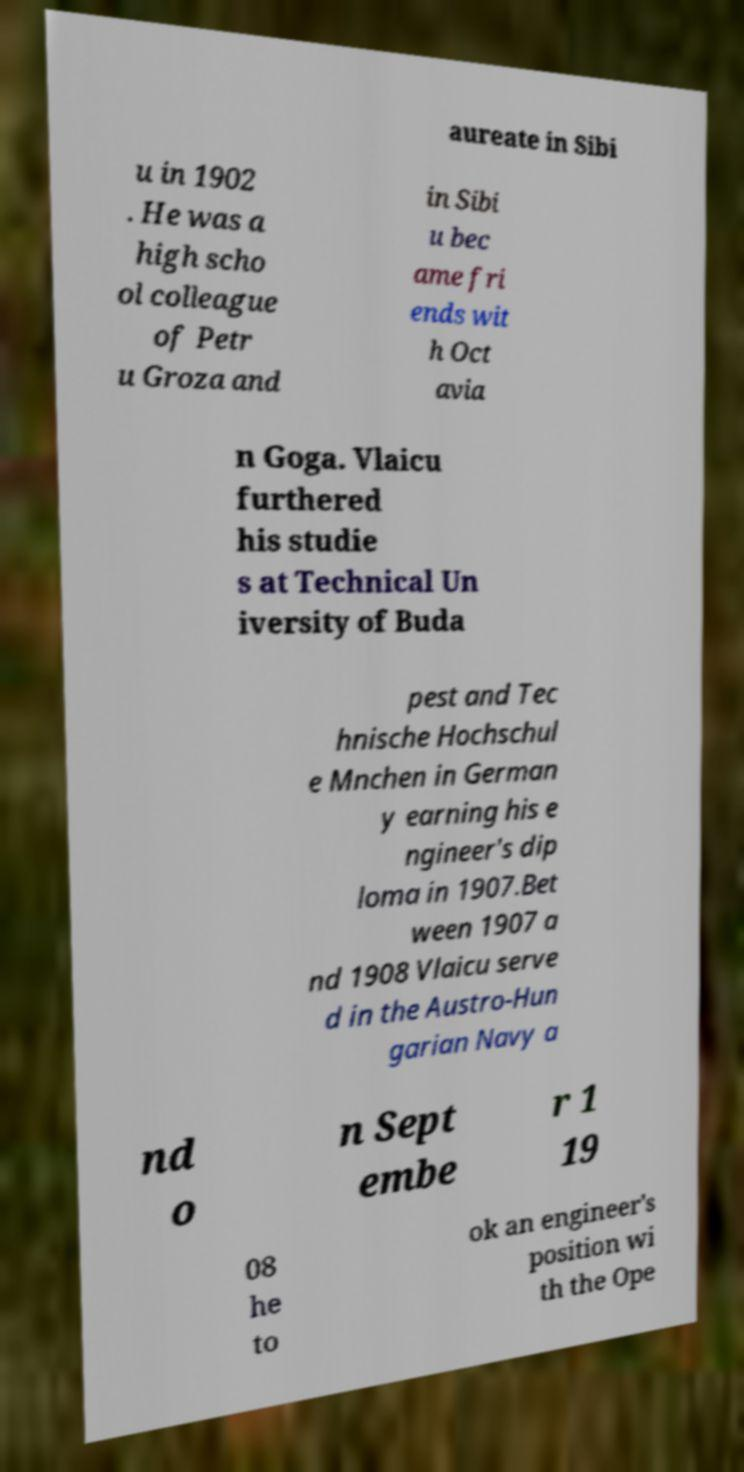Can you accurately transcribe the text from the provided image for me? aureate in Sibi u in 1902 . He was a high scho ol colleague of Petr u Groza and in Sibi u bec ame fri ends wit h Oct avia n Goga. Vlaicu furthered his studie s at Technical Un iversity of Buda pest and Tec hnische Hochschul e Mnchen in German y earning his e ngineer's dip loma in 1907.Bet ween 1907 a nd 1908 Vlaicu serve d in the Austro-Hun garian Navy a nd o n Sept embe r 1 19 08 he to ok an engineer's position wi th the Ope 